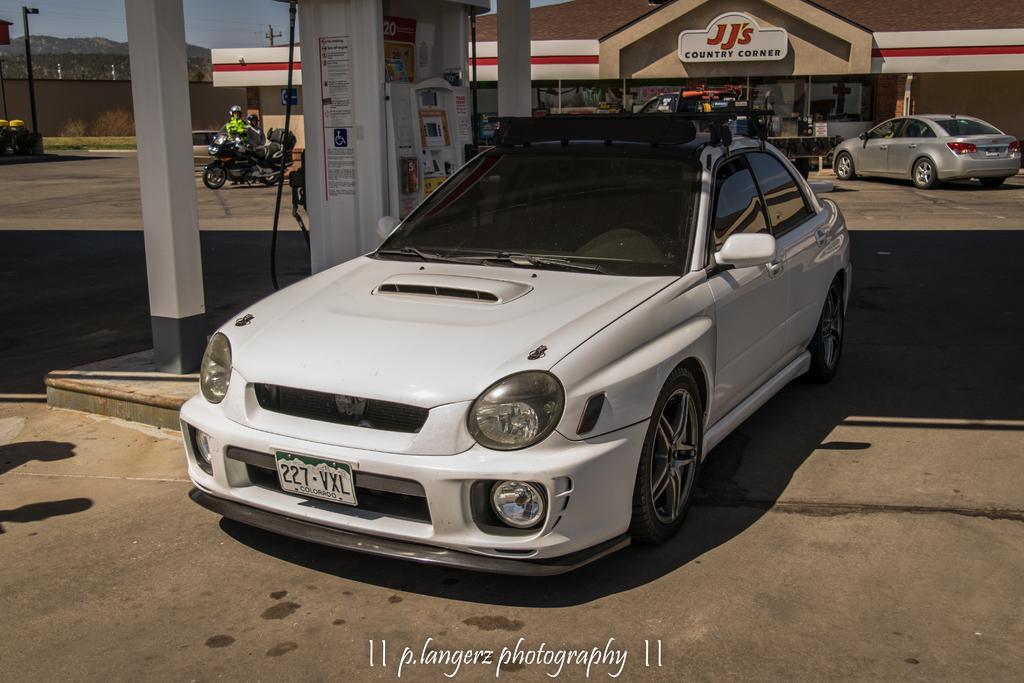Please provide a concise description of this image. In this image I can see few vehicles and I can also see the fuel dispenser. In the background I can see few stalls, light poles, trees and the sky is in blue color. 